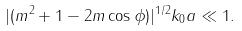Convert formula to latex. <formula><loc_0><loc_0><loc_500><loc_500>| ( m ^ { 2 } + 1 - 2 m \cos \phi ) | ^ { 1 / 2 } k _ { 0 } a \ll 1 .</formula> 